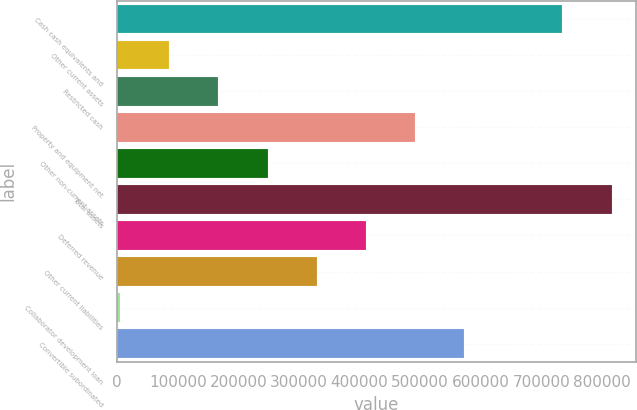<chart> <loc_0><loc_0><loc_500><loc_500><bar_chart><fcel>Cash cash equivalents and<fcel>Other current assets<fcel>Restricted cash<fcel>Property and equipment net<fcel>Other non-current assets<fcel>Total assets<fcel>Deferred revenue<fcel>Other current liabilities<fcel>Collaborator development loan<fcel>Convertible subordinated<nl><fcel>734648<fcel>86072<fcel>167144<fcel>491432<fcel>248216<fcel>815720<fcel>410360<fcel>329288<fcel>5000<fcel>572504<nl></chart> 